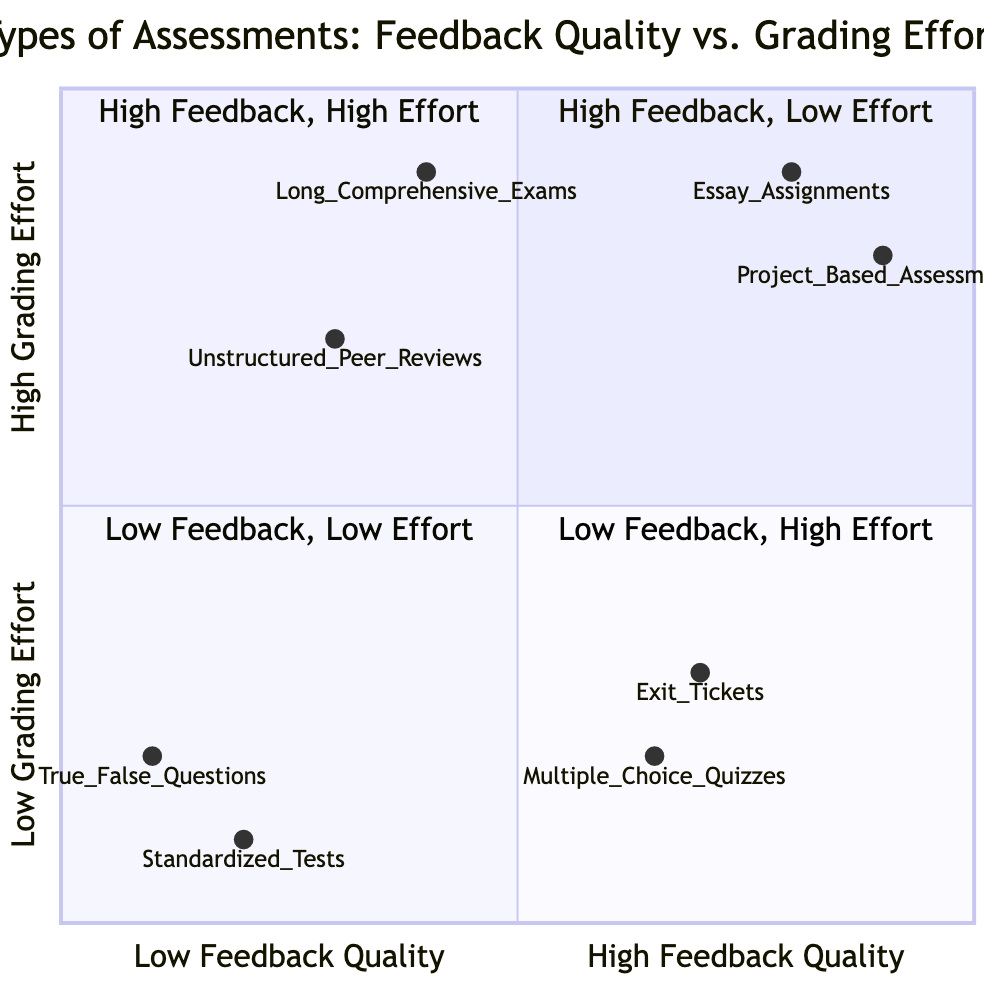What examples are in the "High Feedback Quality, Low Grading Effort" quadrant? This quadrant contains assessments that provide high-quality feedback but require minimal grading effort. The examples listed for this quadrant are "Exit Tickets" and "Multiple Choice Quizzes with Automated Grading."
Answer: Exit Tickets, Multiple Choice Quizzes with Automated Grading Which quadrant has "Essay Assignments" as an example? "Essay Assignments" are found in the "High Feedback Quality, High Grading Effort" quadrant, which is characterized by assessments that provide detailed feedback but require substantial grading effort.
Answer: High Feedback Quality, High Grading Effort How many examples are listed in the "Low Feedback Quality, Low Grading Effort" quadrant? There are two examples listed in the "Low Feedback Quality, Low Grading Effort" quadrant: "Standardized Tests" and "True/False Questions," indicating a basic level of feedback with low grading efforts.
Answer: 2 Which assessment type has the lowest grading effort? The assessment with the lowest grading effort is in the "Low Feedback Quality, Low Grading Effort" quadrant, namely "Standardized Tests," which typically require minimal grading.
Answer: Standardized Tests What is the relationship between "Project-Based Assessments" and grading effort? "Project-Based Assessments" fall in the "High Feedback Quality, High Grading Effort" quadrant, indicating that they require significant grading efforts while providing valuable feedback.
Answer: High Grading Effort What do the x-axis and y-axis represent in this quadrant chart? The x-axis represents "Feedback Quality," ranging from Low to High, while the y-axis represents "Grading Effort," also ranging from Low to High, creating a framework for visualizing the types of assessments.
Answer: Feedback Quality, Grading Effort Which quadrant combines low feedback quality with high grading effort? This quadrant is named "Low Feedback Quality, High Grading Effort," and it includes assessments that require significant grading but provide minimal feedback. Examples include "Unstructured Peer Reviews" and "Long Comprehensive Exams without Rubrics."
Answer: Low Feedback Quality, High Grading Effort 